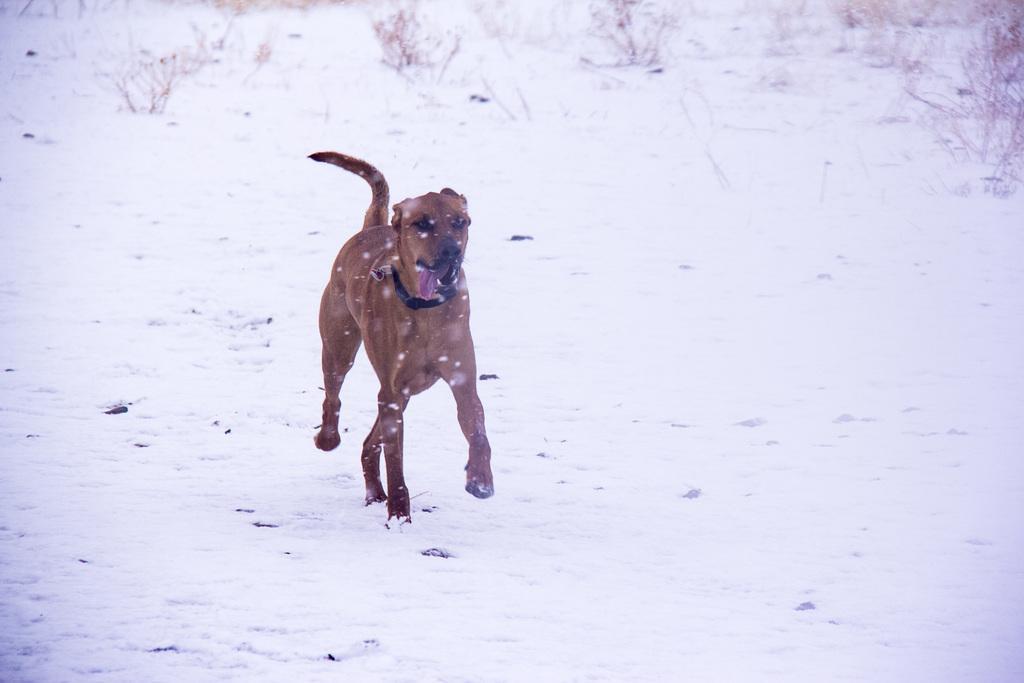Please provide a concise description of this image. This is the picture of a dog which is on the snow floor and behind there are some plants. 